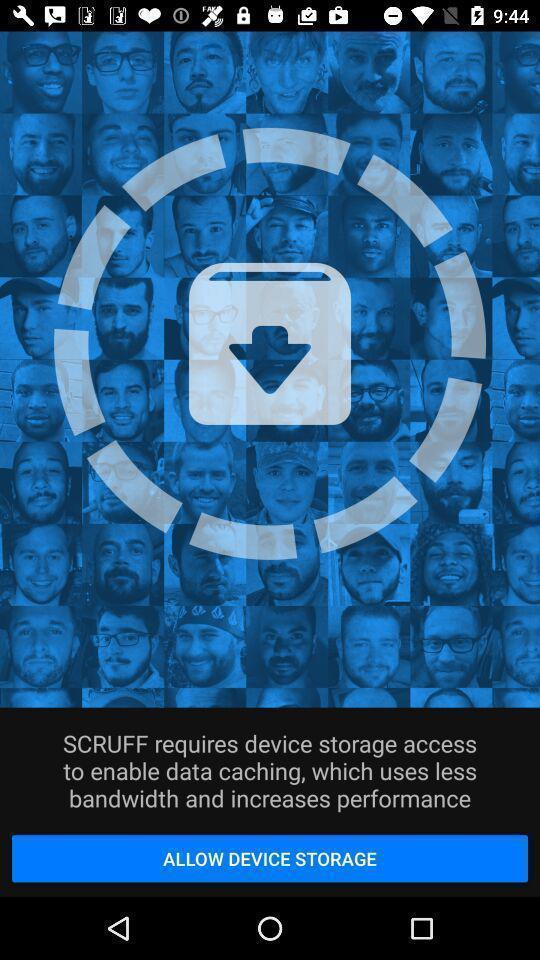Tell me what you see in this picture. Pop up requesting access for device storage. 